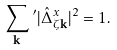<formula> <loc_0><loc_0><loc_500><loc_500>\sum _ { \mathbf k } \, ^ { \prime } | \hat { \Delta } ^ { x } _ { \zeta { \mathbf k } } | ^ { 2 } = 1 .</formula> 